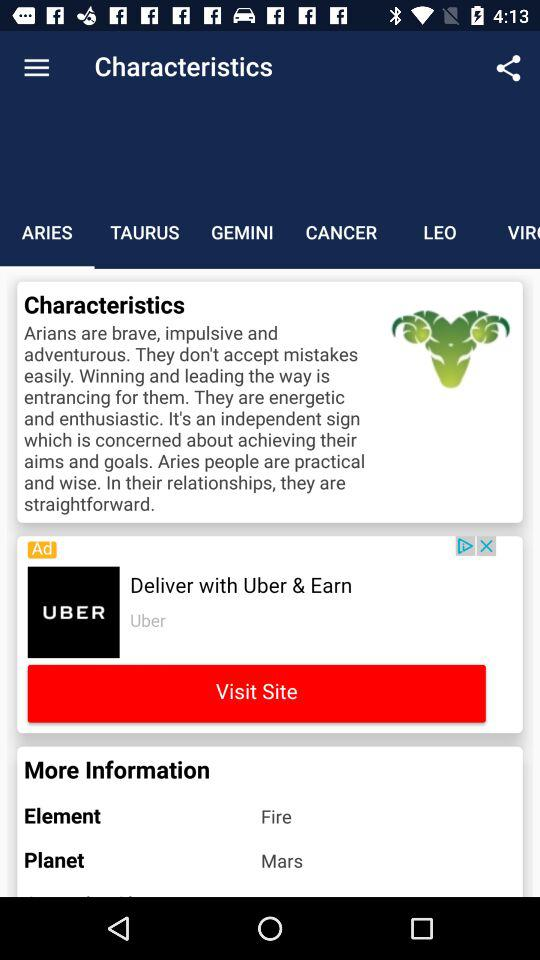What are the characteristics of Arians? Arians are brave, impulsive and adventurous. They don't accept mistakes easily. Winning and leading the way is entrancing for them. They are energetic and enthusiastic. It's an independent sign which is concerned about achieving their aims and goals. Aries people are practical and wise. In their relationships, they are straightforward. 